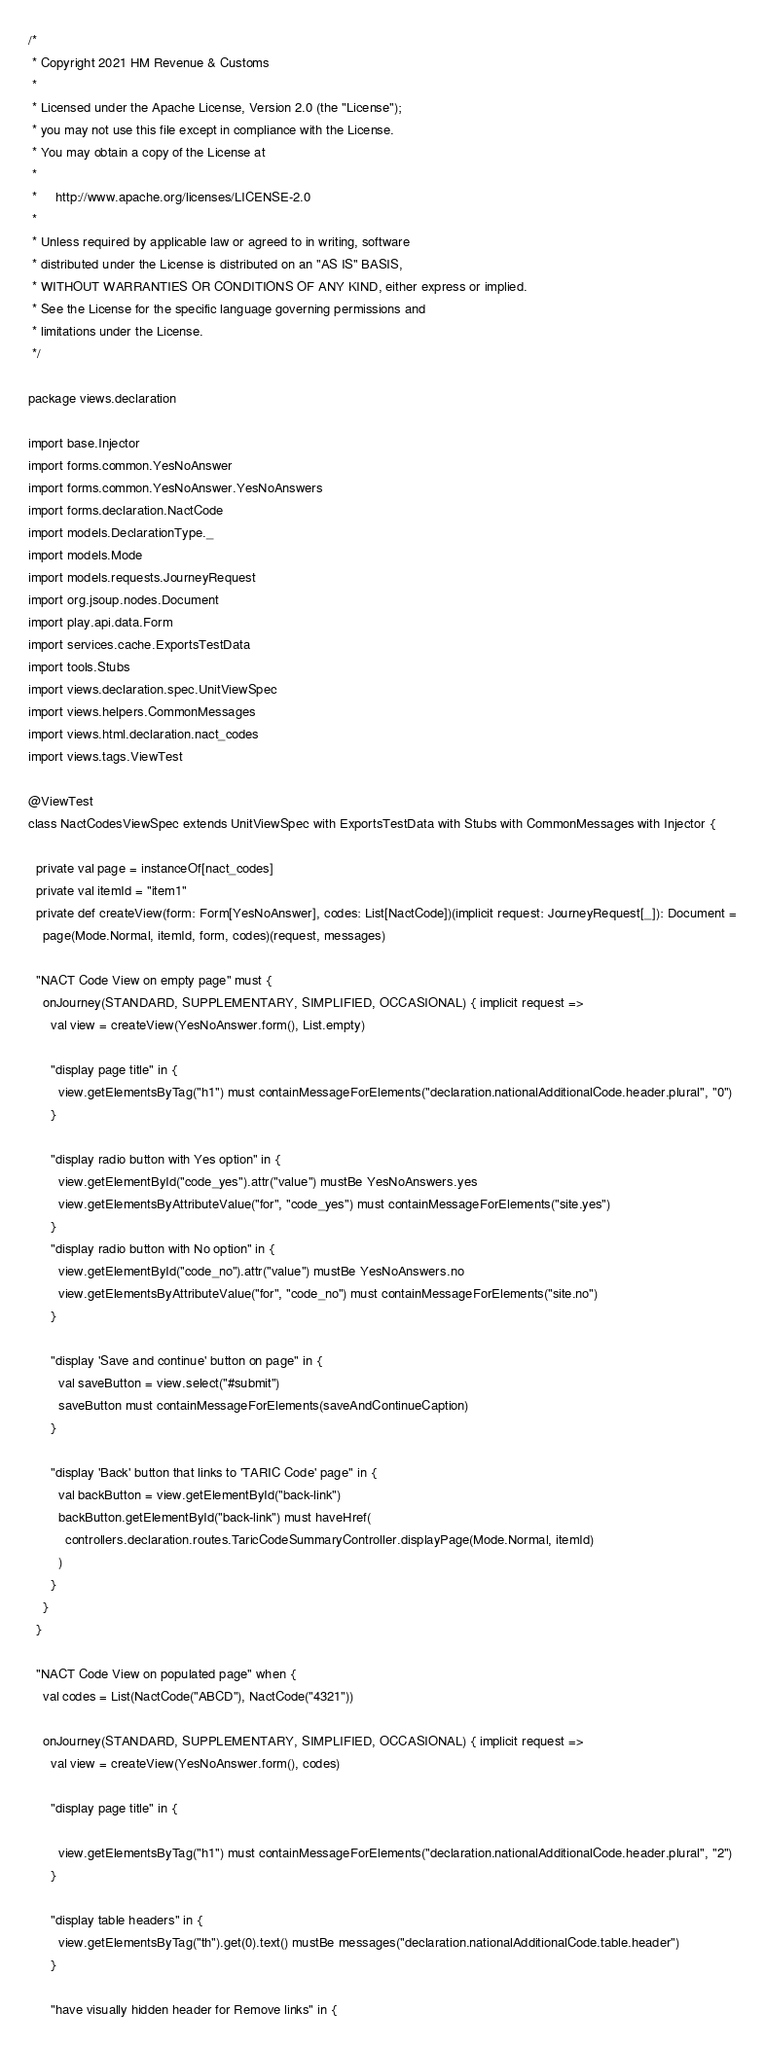Convert code to text. <code><loc_0><loc_0><loc_500><loc_500><_Scala_>/*
 * Copyright 2021 HM Revenue & Customs
 *
 * Licensed under the Apache License, Version 2.0 (the "License");
 * you may not use this file except in compliance with the License.
 * You may obtain a copy of the License at
 *
 *     http://www.apache.org/licenses/LICENSE-2.0
 *
 * Unless required by applicable law or agreed to in writing, software
 * distributed under the License is distributed on an "AS IS" BASIS,
 * WITHOUT WARRANTIES OR CONDITIONS OF ANY KIND, either express or implied.
 * See the License for the specific language governing permissions and
 * limitations under the License.
 */

package views.declaration

import base.Injector
import forms.common.YesNoAnswer
import forms.common.YesNoAnswer.YesNoAnswers
import forms.declaration.NactCode
import models.DeclarationType._
import models.Mode
import models.requests.JourneyRequest
import org.jsoup.nodes.Document
import play.api.data.Form
import services.cache.ExportsTestData
import tools.Stubs
import views.declaration.spec.UnitViewSpec
import views.helpers.CommonMessages
import views.html.declaration.nact_codes
import views.tags.ViewTest

@ViewTest
class NactCodesViewSpec extends UnitViewSpec with ExportsTestData with Stubs with CommonMessages with Injector {

  private val page = instanceOf[nact_codes]
  private val itemId = "item1"
  private def createView(form: Form[YesNoAnswer], codes: List[NactCode])(implicit request: JourneyRequest[_]): Document =
    page(Mode.Normal, itemId, form, codes)(request, messages)

  "NACT Code View on empty page" must {
    onJourney(STANDARD, SUPPLEMENTARY, SIMPLIFIED, OCCASIONAL) { implicit request =>
      val view = createView(YesNoAnswer.form(), List.empty)

      "display page title" in {
        view.getElementsByTag("h1") must containMessageForElements("declaration.nationalAdditionalCode.header.plural", "0")
      }

      "display radio button with Yes option" in {
        view.getElementById("code_yes").attr("value") mustBe YesNoAnswers.yes
        view.getElementsByAttributeValue("for", "code_yes") must containMessageForElements("site.yes")
      }
      "display radio button with No option" in {
        view.getElementById("code_no").attr("value") mustBe YesNoAnswers.no
        view.getElementsByAttributeValue("for", "code_no") must containMessageForElements("site.no")
      }

      "display 'Save and continue' button on page" in {
        val saveButton = view.select("#submit")
        saveButton must containMessageForElements(saveAndContinueCaption)
      }

      "display 'Back' button that links to 'TARIC Code' page" in {
        val backButton = view.getElementById("back-link")
        backButton.getElementById("back-link") must haveHref(
          controllers.declaration.routes.TaricCodeSummaryController.displayPage(Mode.Normal, itemId)
        )
      }
    }
  }

  "NACT Code View on populated page" when {
    val codes = List(NactCode("ABCD"), NactCode("4321"))

    onJourney(STANDARD, SUPPLEMENTARY, SIMPLIFIED, OCCASIONAL) { implicit request =>
      val view = createView(YesNoAnswer.form(), codes)

      "display page title" in {

        view.getElementsByTag("h1") must containMessageForElements("declaration.nationalAdditionalCode.header.plural", "2")
      }

      "display table headers" in {
        view.getElementsByTag("th").get(0).text() mustBe messages("declaration.nationalAdditionalCode.table.header")
      }

      "have visually hidden header for Remove links" in {</code> 